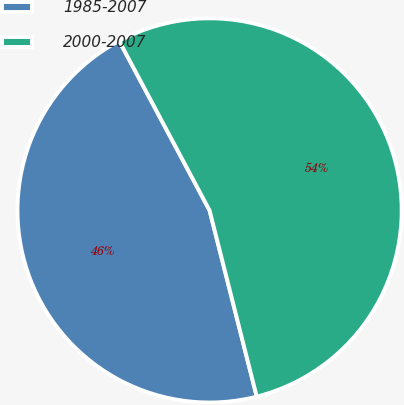<chart> <loc_0><loc_0><loc_500><loc_500><pie_chart><fcel>1985-2007<fcel>2000-2007<nl><fcel>46.15%<fcel>53.85%<nl></chart> 